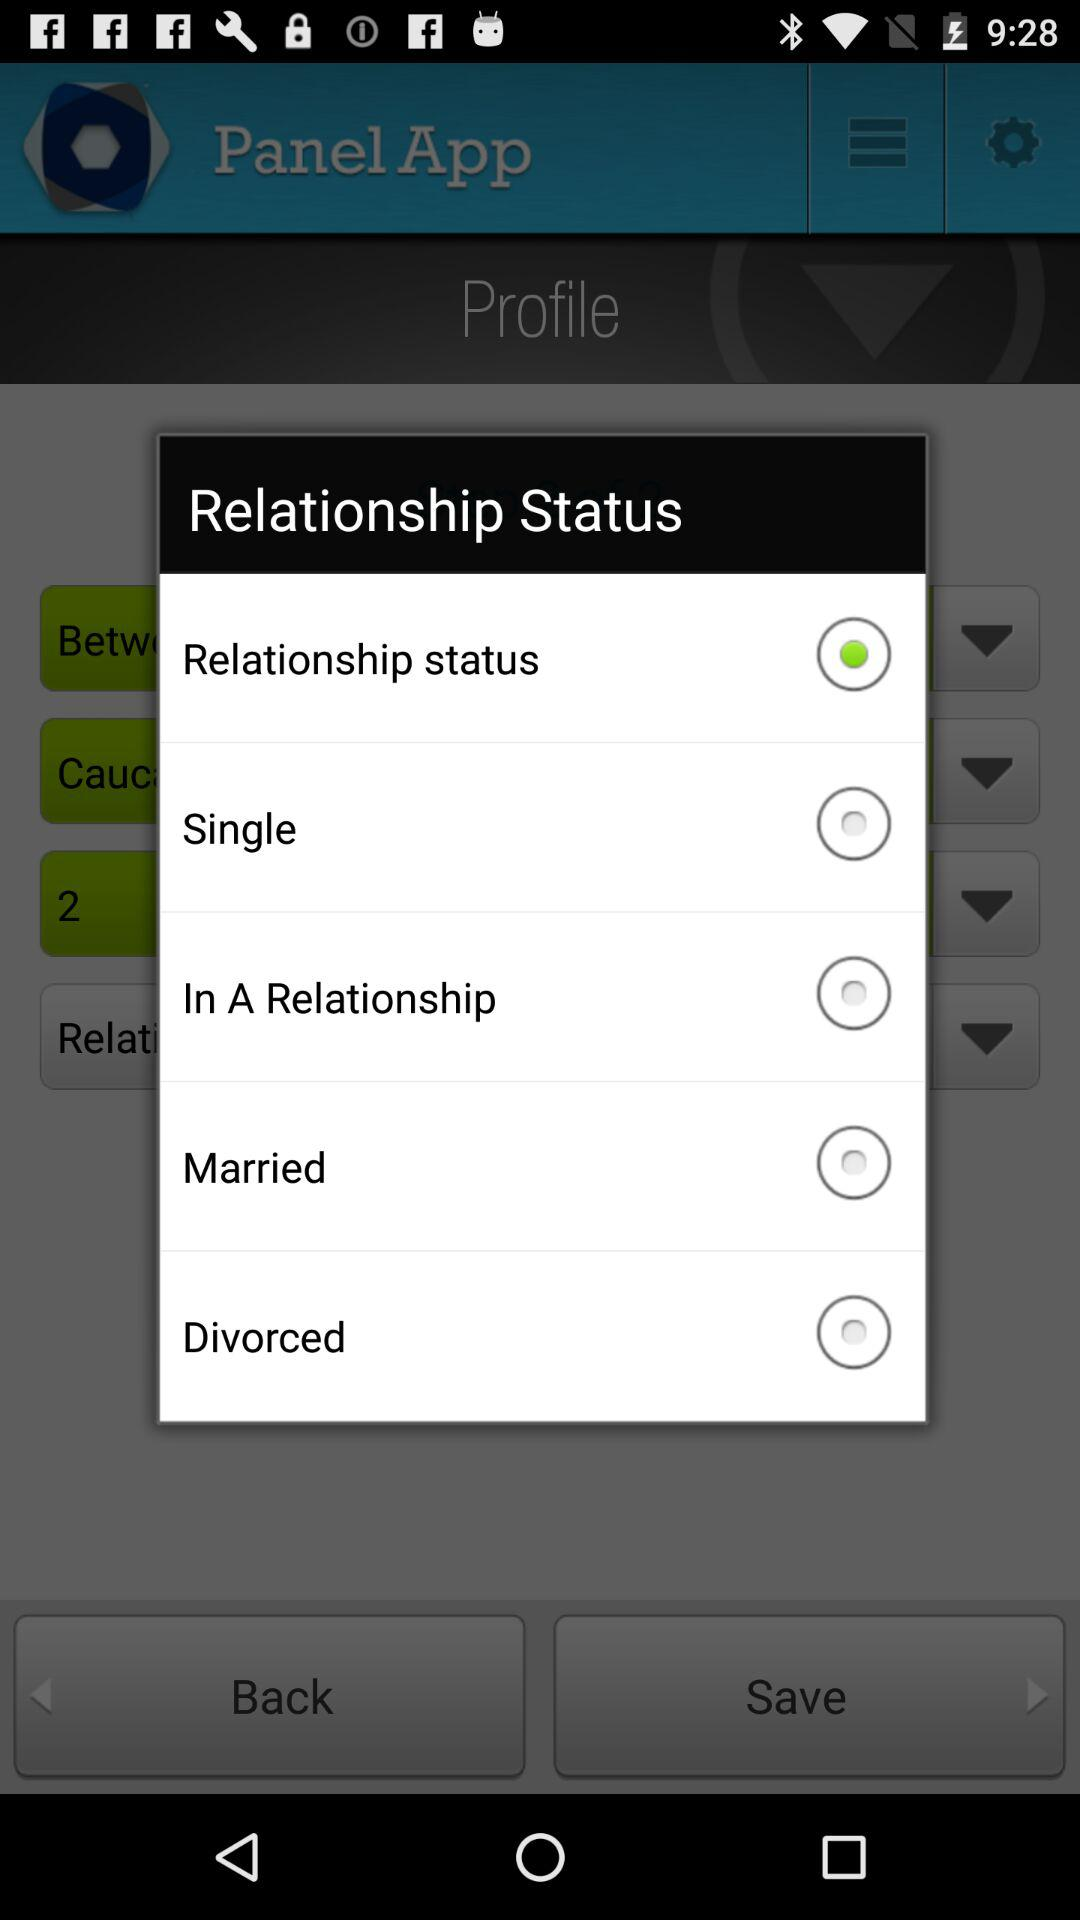How many relationship options are there?
Answer the question using a single word or phrase. 5 